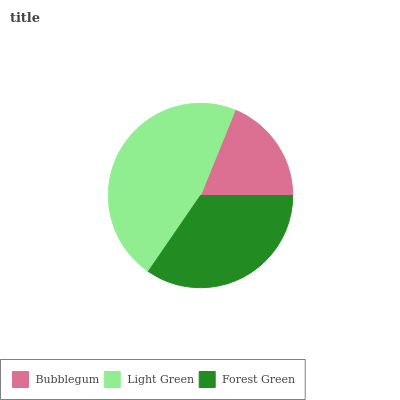Is Bubblegum the minimum?
Answer yes or no. Yes. Is Light Green the maximum?
Answer yes or no. Yes. Is Forest Green the minimum?
Answer yes or no. No. Is Forest Green the maximum?
Answer yes or no. No. Is Light Green greater than Forest Green?
Answer yes or no. Yes. Is Forest Green less than Light Green?
Answer yes or no. Yes. Is Forest Green greater than Light Green?
Answer yes or no. No. Is Light Green less than Forest Green?
Answer yes or no. No. Is Forest Green the high median?
Answer yes or no. Yes. Is Forest Green the low median?
Answer yes or no. Yes. Is Bubblegum the high median?
Answer yes or no. No. Is Light Green the low median?
Answer yes or no. No. 